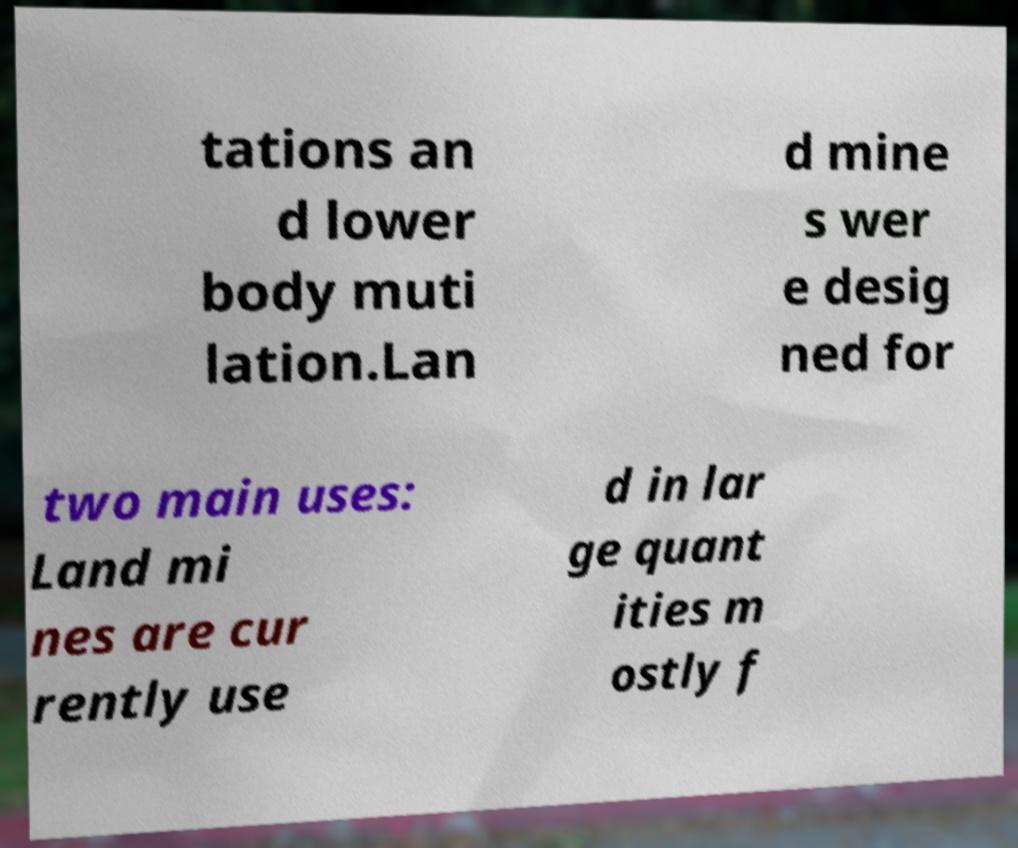There's text embedded in this image that I need extracted. Can you transcribe it verbatim? tations an d lower body muti lation.Lan d mine s wer e desig ned for two main uses: Land mi nes are cur rently use d in lar ge quant ities m ostly f 